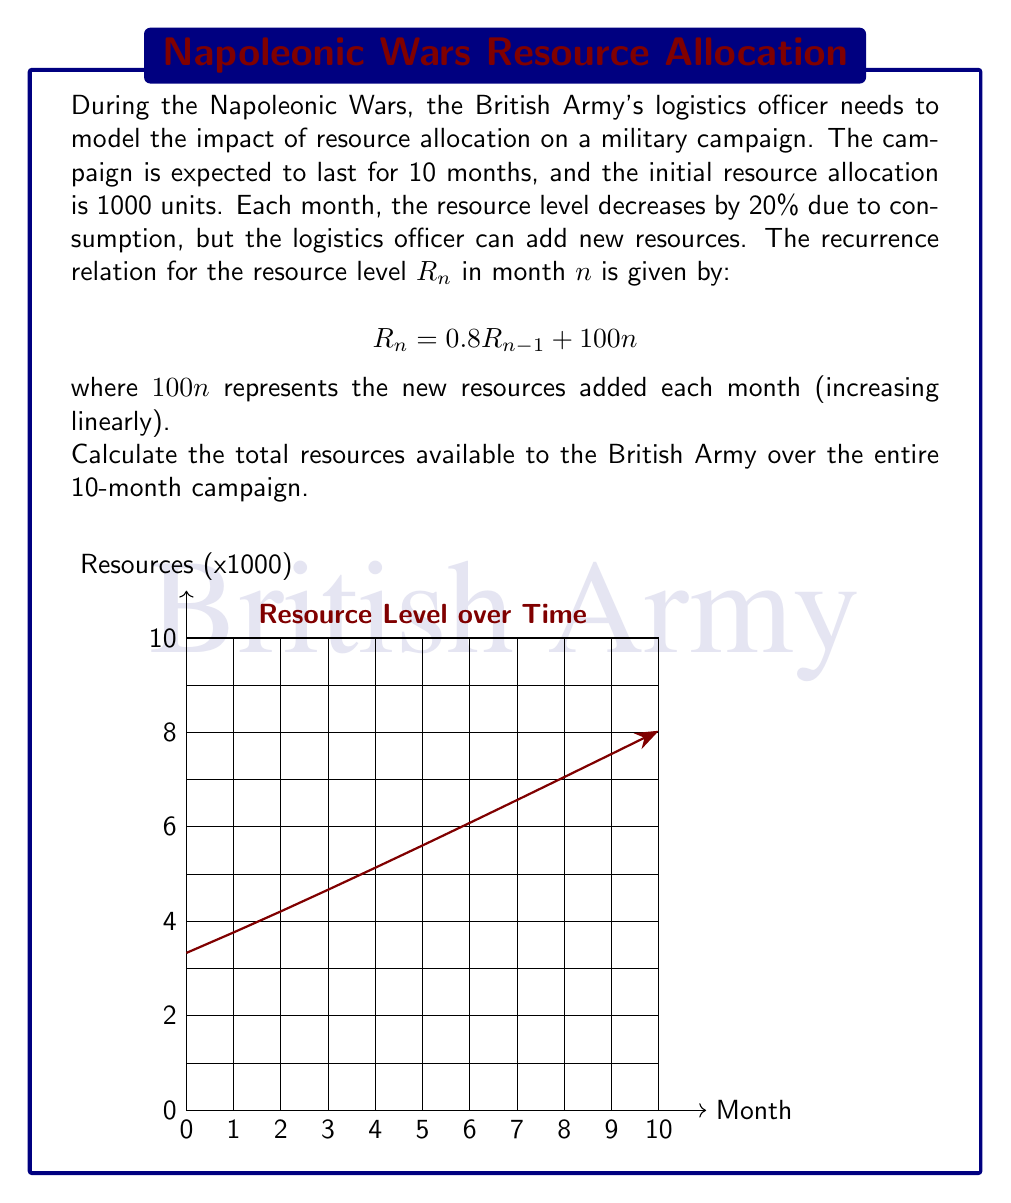What is the answer to this math problem? To solve this problem, we'll follow these steps:

1) First, let's calculate the resource level for each month using the given recurrence relation:

   $R_0 = 1000$ (initial resource level)
   $R_1 = 0.8(1000) + 100(1) = 900$
   $R_2 = 0.8(900) + 100(2) = 920$
   $R_3 = 0.8(920) + 100(3) = 1036$
   ...and so on.

2) We can continue this calculation for all 10 months:

   $R_4 = 1228.8$
   $R_5 = 1483.04$
   $R_6 = 1786.432$
   $R_7 = 2129.1456$
   $R_8 = 2503.31648$
   $R_9 = 2902.653184$
   $R_{10} = 3322.1225472$

3) To find the total resources available over the entire campaign, we need to sum all these values, including the initial resource level:

   Total = $1000 + 900 + 920 + 1036 + 1228.8 + 1483.04 + 1786.432 + 2129.1456 + 2503.31648 + 2902.653184 + 3322.1225472$

4) Summing these values:

   Total ≈ 19211.51 (rounded to 2 decimal places)

Therefore, the total resources available to the British Army over the entire 10-month campaign is approximately 19211.51 units.
Answer: 19211.51 units 